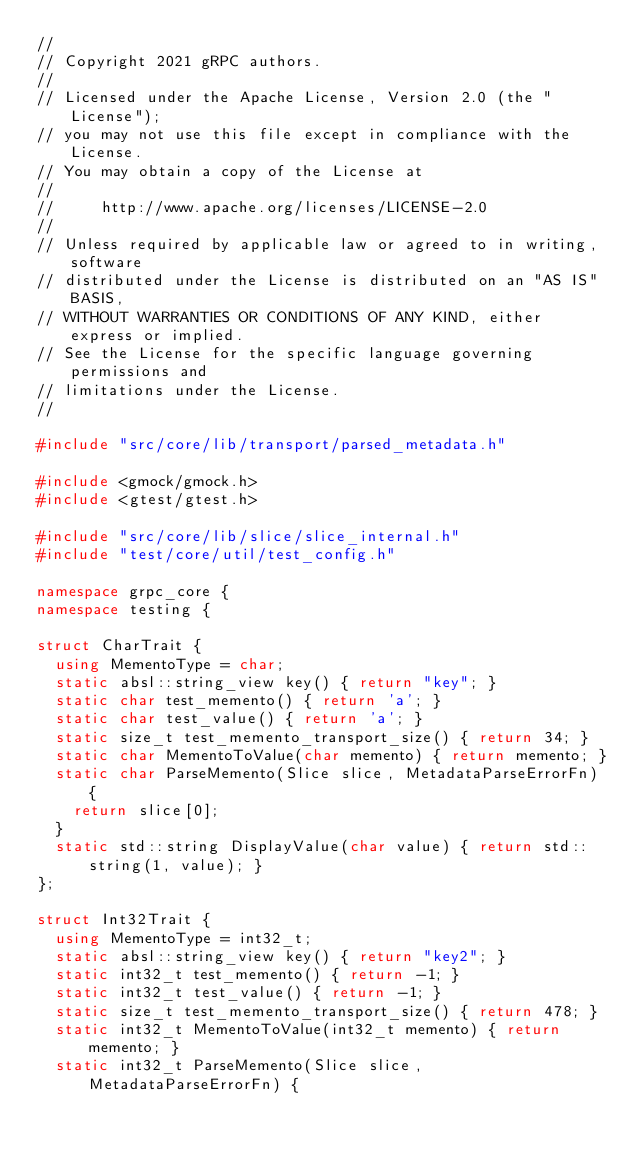Convert code to text. <code><loc_0><loc_0><loc_500><loc_500><_C++_>//
// Copyright 2021 gRPC authors.
//
// Licensed under the Apache License, Version 2.0 (the "License");
// you may not use this file except in compliance with the License.
// You may obtain a copy of the License at
//
//     http://www.apache.org/licenses/LICENSE-2.0
//
// Unless required by applicable law or agreed to in writing, software
// distributed under the License is distributed on an "AS IS" BASIS,
// WITHOUT WARRANTIES OR CONDITIONS OF ANY KIND, either express or implied.
// See the License for the specific language governing permissions and
// limitations under the License.
//

#include "src/core/lib/transport/parsed_metadata.h"

#include <gmock/gmock.h>
#include <gtest/gtest.h>

#include "src/core/lib/slice/slice_internal.h"
#include "test/core/util/test_config.h"

namespace grpc_core {
namespace testing {

struct CharTrait {
  using MementoType = char;
  static absl::string_view key() { return "key"; }
  static char test_memento() { return 'a'; }
  static char test_value() { return 'a'; }
  static size_t test_memento_transport_size() { return 34; }
  static char MementoToValue(char memento) { return memento; }
  static char ParseMemento(Slice slice, MetadataParseErrorFn) {
    return slice[0];
  }
  static std::string DisplayValue(char value) { return std::string(1, value); }
};

struct Int32Trait {
  using MementoType = int32_t;
  static absl::string_view key() { return "key2"; }
  static int32_t test_memento() { return -1; }
  static int32_t test_value() { return -1; }
  static size_t test_memento_transport_size() { return 478; }
  static int32_t MementoToValue(int32_t memento) { return memento; }
  static int32_t ParseMemento(Slice slice, MetadataParseErrorFn) {</code> 